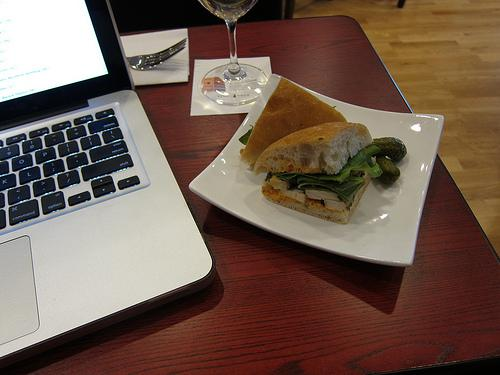Question: where is the sandwich?
Choices:
A. On the table.
B. On a napkin.
C. On a cart.
D. On the plate.
Answer with the letter. Answer: D Question: what type of glass is on the desk?
Choices:
A. Drinking glass.
B. Beer glass.
C. Wine Glass.
D. Soda glass bottle.
Answer with the letter. Answer: C Question: how is the sandwich cut?
Choices:
A. In half.
B. In thirds.
C. In quarters.
D. In  threes.
Answer with the letter. Answer: A Question: what type of flooring is it?
Choices:
A. Tile.
B. Wood.
C. Carpet.
D. Vinyl.
Answer with the letter. Answer: B Question: what is the plate on?
Choices:
A. The chair.
B. The table.
C. The desk.
D. On a tray.
Answer with the letter. Answer: C Question: what is on the plate?
Choices:
A. A sandwich.
B. A burger.
C. A steak.
D. Pasta.
Answer with the letter. Answer: A 